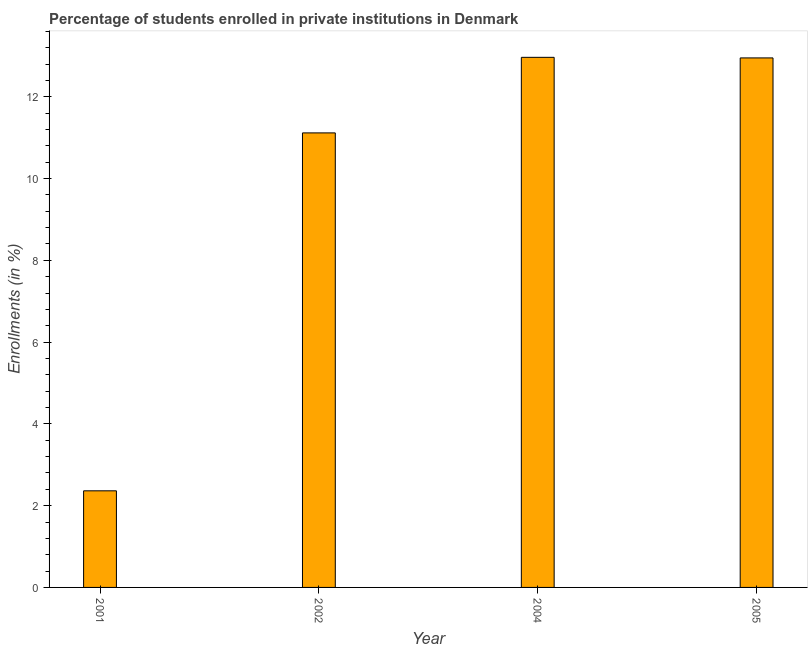Does the graph contain any zero values?
Keep it short and to the point. No. Does the graph contain grids?
Make the answer very short. No. What is the title of the graph?
Offer a very short reply. Percentage of students enrolled in private institutions in Denmark. What is the label or title of the Y-axis?
Make the answer very short. Enrollments (in %). What is the enrollments in private institutions in 2001?
Ensure brevity in your answer.  2.36. Across all years, what is the maximum enrollments in private institutions?
Offer a very short reply. 12.96. Across all years, what is the minimum enrollments in private institutions?
Offer a terse response. 2.36. In which year was the enrollments in private institutions maximum?
Provide a succinct answer. 2004. In which year was the enrollments in private institutions minimum?
Offer a very short reply. 2001. What is the sum of the enrollments in private institutions?
Make the answer very short. 39.39. What is the difference between the enrollments in private institutions in 2002 and 2005?
Your answer should be compact. -1.83. What is the average enrollments in private institutions per year?
Make the answer very short. 9.85. What is the median enrollments in private institutions?
Provide a succinct answer. 12.03. Do a majority of the years between 2001 and 2005 (inclusive) have enrollments in private institutions greater than 2.8 %?
Keep it short and to the point. Yes. What is the ratio of the enrollments in private institutions in 2001 to that in 2004?
Offer a terse response. 0.18. Is the difference between the enrollments in private institutions in 2002 and 2004 greater than the difference between any two years?
Provide a succinct answer. No. What is the difference between the highest and the second highest enrollments in private institutions?
Keep it short and to the point. 0.01. What is the difference between the highest and the lowest enrollments in private institutions?
Provide a succinct answer. 10.6. What is the difference between two consecutive major ticks on the Y-axis?
Make the answer very short. 2. Are the values on the major ticks of Y-axis written in scientific E-notation?
Make the answer very short. No. What is the Enrollments (in %) of 2001?
Provide a succinct answer. 2.36. What is the Enrollments (in %) of 2002?
Make the answer very short. 11.12. What is the Enrollments (in %) in 2004?
Offer a very short reply. 12.96. What is the Enrollments (in %) in 2005?
Make the answer very short. 12.95. What is the difference between the Enrollments (in %) in 2001 and 2002?
Offer a terse response. -8.75. What is the difference between the Enrollments (in %) in 2001 and 2004?
Offer a terse response. -10.6. What is the difference between the Enrollments (in %) in 2001 and 2005?
Offer a very short reply. -10.59. What is the difference between the Enrollments (in %) in 2002 and 2004?
Offer a very short reply. -1.85. What is the difference between the Enrollments (in %) in 2002 and 2005?
Your answer should be very brief. -1.83. What is the difference between the Enrollments (in %) in 2004 and 2005?
Provide a succinct answer. 0.01. What is the ratio of the Enrollments (in %) in 2001 to that in 2002?
Offer a terse response. 0.21. What is the ratio of the Enrollments (in %) in 2001 to that in 2004?
Make the answer very short. 0.18. What is the ratio of the Enrollments (in %) in 2001 to that in 2005?
Make the answer very short. 0.18. What is the ratio of the Enrollments (in %) in 2002 to that in 2004?
Offer a terse response. 0.86. What is the ratio of the Enrollments (in %) in 2002 to that in 2005?
Ensure brevity in your answer.  0.86. What is the ratio of the Enrollments (in %) in 2004 to that in 2005?
Your response must be concise. 1. 